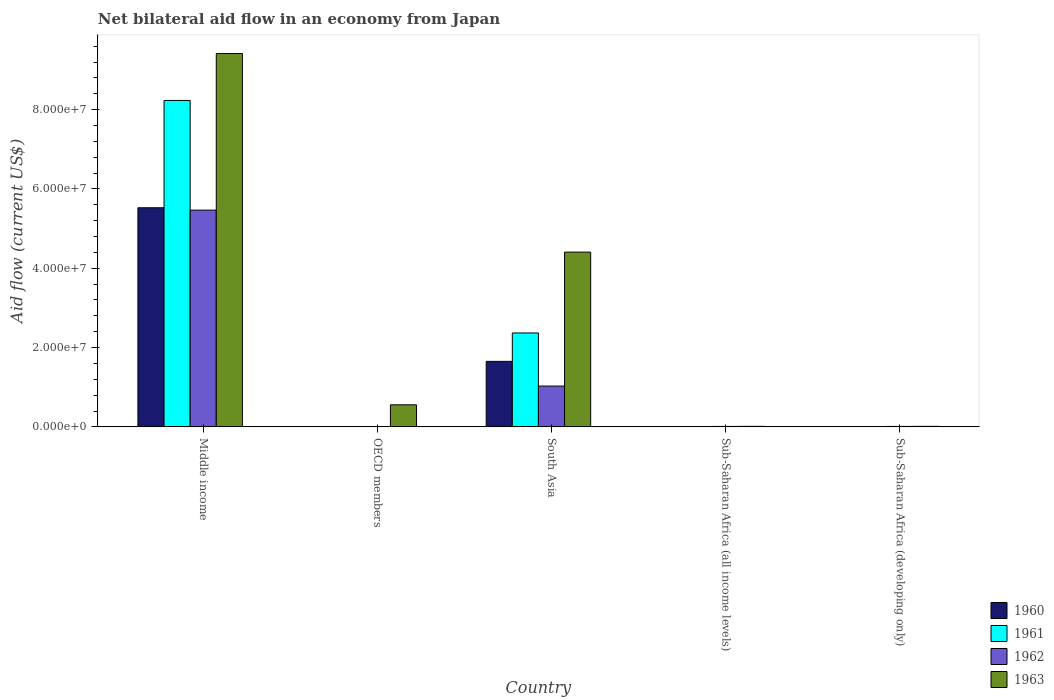How many groups of bars are there?
Keep it short and to the point. 5. Are the number of bars per tick equal to the number of legend labels?
Ensure brevity in your answer.  Yes. How many bars are there on the 2nd tick from the right?
Your response must be concise. 4. What is the label of the 4th group of bars from the left?
Give a very brief answer. Sub-Saharan Africa (all income levels). In how many cases, is the number of bars for a given country not equal to the number of legend labels?
Your response must be concise. 0. What is the net bilateral aid flow in 1963 in OECD members?
Provide a short and direct response. 5.56e+06. Across all countries, what is the maximum net bilateral aid flow in 1961?
Keep it short and to the point. 8.23e+07. What is the total net bilateral aid flow in 1960 in the graph?
Provide a succinct answer. 7.18e+07. What is the difference between the net bilateral aid flow in 1963 in South Asia and that in Sub-Saharan Africa (all income levels)?
Your answer should be very brief. 4.39e+07. What is the difference between the net bilateral aid flow in 1961 in South Asia and the net bilateral aid flow in 1960 in OECD members?
Your answer should be very brief. 2.36e+07. What is the average net bilateral aid flow in 1961 per country?
Give a very brief answer. 2.12e+07. What is the difference between the net bilateral aid flow of/in 1962 and net bilateral aid flow of/in 1961 in Sub-Saharan Africa (all income levels)?
Your answer should be very brief. 8.00e+04. What is the ratio of the net bilateral aid flow in 1961 in OECD members to that in South Asia?
Your answer should be very brief. 0. What is the difference between the highest and the second highest net bilateral aid flow in 1960?
Provide a succinct answer. 5.52e+07. What is the difference between the highest and the lowest net bilateral aid flow in 1961?
Give a very brief answer. 8.23e+07. What does the 4th bar from the right in South Asia represents?
Keep it short and to the point. 1960. Are the values on the major ticks of Y-axis written in scientific E-notation?
Ensure brevity in your answer.  Yes. What is the title of the graph?
Give a very brief answer. Net bilateral aid flow in an economy from Japan. What is the Aid flow (current US$) in 1960 in Middle income?
Ensure brevity in your answer.  5.53e+07. What is the Aid flow (current US$) of 1961 in Middle income?
Keep it short and to the point. 8.23e+07. What is the Aid flow (current US$) in 1962 in Middle income?
Your response must be concise. 5.47e+07. What is the Aid flow (current US$) of 1963 in Middle income?
Offer a very short reply. 9.42e+07. What is the Aid flow (current US$) in 1960 in OECD members?
Give a very brief answer. 3.00e+04. What is the Aid flow (current US$) in 1963 in OECD members?
Your answer should be very brief. 5.56e+06. What is the Aid flow (current US$) in 1960 in South Asia?
Offer a very short reply. 1.65e+07. What is the Aid flow (current US$) in 1961 in South Asia?
Your answer should be very brief. 2.37e+07. What is the Aid flow (current US$) in 1962 in South Asia?
Your response must be concise. 1.03e+07. What is the Aid flow (current US$) of 1963 in South Asia?
Make the answer very short. 4.41e+07. What is the Aid flow (current US$) of 1962 in Sub-Saharan Africa (all income levels)?
Offer a terse response. 1.10e+05. Across all countries, what is the maximum Aid flow (current US$) of 1960?
Keep it short and to the point. 5.53e+07. Across all countries, what is the maximum Aid flow (current US$) of 1961?
Make the answer very short. 8.23e+07. Across all countries, what is the maximum Aid flow (current US$) of 1962?
Offer a very short reply. 5.47e+07. Across all countries, what is the maximum Aid flow (current US$) of 1963?
Provide a succinct answer. 9.42e+07. Across all countries, what is the minimum Aid flow (current US$) of 1961?
Your answer should be compact. 3.00e+04. Across all countries, what is the minimum Aid flow (current US$) of 1962?
Offer a terse response. 9.00e+04. What is the total Aid flow (current US$) in 1960 in the graph?
Offer a terse response. 7.18e+07. What is the total Aid flow (current US$) of 1961 in the graph?
Make the answer very short. 1.06e+08. What is the total Aid flow (current US$) in 1962 in the graph?
Your response must be concise. 6.53e+07. What is the total Aid flow (current US$) in 1963 in the graph?
Your answer should be very brief. 1.44e+08. What is the difference between the Aid flow (current US$) of 1960 in Middle income and that in OECD members?
Make the answer very short. 5.52e+07. What is the difference between the Aid flow (current US$) in 1961 in Middle income and that in OECD members?
Offer a terse response. 8.23e+07. What is the difference between the Aid flow (current US$) of 1962 in Middle income and that in OECD members?
Offer a very short reply. 5.46e+07. What is the difference between the Aid flow (current US$) in 1963 in Middle income and that in OECD members?
Ensure brevity in your answer.  8.86e+07. What is the difference between the Aid flow (current US$) of 1960 in Middle income and that in South Asia?
Ensure brevity in your answer.  3.87e+07. What is the difference between the Aid flow (current US$) of 1961 in Middle income and that in South Asia?
Make the answer very short. 5.86e+07. What is the difference between the Aid flow (current US$) in 1962 in Middle income and that in South Asia?
Give a very brief answer. 4.44e+07. What is the difference between the Aid flow (current US$) in 1963 in Middle income and that in South Asia?
Provide a short and direct response. 5.01e+07. What is the difference between the Aid flow (current US$) of 1960 in Middle income and that in Sub-Saharan Africa (all income levels)?
Offer a very short reply. 5.52e+07. What is the difference between the Aid flow (current US$) in 1961 in Middle income and that in Sub-Saharan Africa (all income levels)?
Keep it short and to the point. 8.23e+07. What is the difference between the Aid flow (current US$) of 1962 in Middle income and that in Sub-Saharan Africa (all income levels)?
Offer a very short reply. 5.46e+07. What is the difference between the Aid flow (current US$) of 1963 in Middle income and that in Sub-Saharan Africa (all income levels)?
Offer a very short reply. 9.40e+07. What is the difference between the Aid flow (current US$) in 1960 in Middle income and that in Sub-Saharan Africa (developing only)?
Give a very brief answer. 5.52e+07. What is the difference between the Aid flow (current US$) in 1961 in Middle income and that in Sub-Saharan Africa (developing only)?
Make the answer very short. 8.23e+07. What is the difference between the Aid flow (current US$) of 1962 in Middle income and that in Sub-Saharan Africa (developing only)?
Provide a succinct answer. 5.46e+07. What is the difference between the Aid flow (current US$) in 1963 in Middle income and that in Sub-Saharan Africa (developing only)?
Offer a very short reply. 9.40e+07. What is the difference between the Aid flow (current US$) in 1960 in OECD members and that in South Asia?
Keep it short and to the point. -1.65e+07. What is the difference between the Aid flow (current US$) in 1961 in OECD members and that in South Asia?
Give a very brief answer. -2.36e+07. What is the difference between the Aid flow (current US$) of 1962 in OECD members and that in South Asia?
Ensure brevity in your answer.  -1.02e+07. What is the difference between the Aid flow (current US$) in 1963 in OECD members and that in South Asia?
Make the answer very short. -3.85e+07. What is the difference between the Aid flow (current US$) of 1962 in OECD members and that in Sub-Saharan Africa (all income levels)?
Offer a terse response. -2.00e+04. What is the difference between the Aid flow (current US$) of 1963 in OECD members and that in Sub-Saharan Africa (all income levels)?
Your response must be concise. 5.43e+06. What is the difference between the Aid flow (current US$) of 1963 in OECD members and that in Sub-Saharan Africa (developing only)?
Make the answer very short. 5.43e+06. What is the difference between the Aid flow (current US$) of 1960 in South Asia and that in Sub-Saharan Africa (all income levels)?
Provide a short and direct response. 1.65e+07. What is the difference between the Aid flow (current US$) in 1961 in South Asia and that in Sub-Saharan Africa (all income levels)?
Keep it short and to the point. 2.36e+07. What is the difference between the Aid flow (current US$) in 1962 in South Asia and that in Sub-Saharan Africa (all income levels)?
Ensure brevity in your answer.  1.02e+07. What is the difference between the Aid flow (current US$) of 1963 in South Asia and that in Sub-Saharan Africa (all income levels)?
Give a very brief answer. 4.39e+07. What is the difference between the Aid flow (current US$) in 1960 in South Asia and that in Sub-Saharan Africa (developing only)?
Keep it short and to the point. 1.65e+07. What is the difference between the Aid flow (current US$) of 1961 in South Asia and that in Sub-Saharan Africa (developing only)?
Your answer should be very brief. 2.36e+07. What is the difference between the Aid flow (current US$) in 1962 in South Asia and that in Sub-Saharan Africa (developing only)?
Give a very brief answer. 1.02e+07. What is the difference between the Aid flow (current US$) in 1963 in South Asia and that in Sub-Saharan Africa (developing only)?
Your answer should be very brief. 4.39e+07. What is the difference between the Aid flow (current US$) of 1961 in Sub-Saharan Africa (all income levels) and that in Sub-Saharan Africa (developing only)?
Offer a terse response. 0. What is the difference between the Aid flow (current US$) of 1962 in Sub-Saharan Africa (all income levels) and that in Sub-Saharan Africa (developing only)?
Provide a short and direct response. 0. What is the difference between the Aid flow (current US$) in 1963 in Sub-Saharan Africa (all income levels) and that in Sub-Saharan Africa (developing only)?
Your response must be concise. 0. What is the difference between the Aid flow (current US$) of 1960 in Middle income and the Aid flow (current US$) of 1961 in OECD members?
Ensure brevity in your answer.  5.52e+07. What is the difference between the Aid flow (current US$) of 1960 in Middle income and the Aid flow (current US$) of 1962 in OECD members?
Offer a very short reply. 5.52e+07. What is the difference between the Aid flow (current US$) of 1960 in Middle income and the Aid flow (current US$) of 1963 in OECD members?
Provide a succinct answer. 4.97e+07. What is the difference between the Aid flow (current US$) in 1961 in Middle income and the Aid flow (current US$) in 1962 in OECD members?
Keep it short and to the point. 8.22e+07. What is the difference between the Aid flow (current US$) in 1961 in Middle income and the Aid flow (current US$) in 1963 in OECD members?
Keep it short and to the point. 7.68e+07. What is the difference between the Aid flow (current US$) in 1962 in Middle income and the Aid flow (current US$) in 1963 in OECD members?
Keep it short and to the point. 4.91e+07. What is the difference between the Aid flow (current US$) in 1960 in Middle income and the Aid flow (current US$) in 1961 in South Asia?
Provide a succinct answer. 3.16e+07. What is the difference between the Aid flow (current US$) of 1960 in Middle income and the Aid flow (current US$) of 1962 in South Asia?
Your answer should be very brief. 4.50e+07. What is the difference between the Aid flow (current US$) in 1960 in Middle income and the Aid flow (current US$) in 1963 in South Asia?
Provide a succinct answer. 1.12e+07. What is the difference between the Aid flow (current US$) in 1961 in Middle income and the Aid flow (current US$) in 1962 in South Asia?
Your response must be concise. 7.20e+07. What is the difference between the Aid flow (current US$) of 1961 in Middle income and the Aid flow (current US$) of 1963 in South Asia?
Offer a very short reply. 3.82e+07. What is the difference between the Aid flow (current US$) of 1962 in Middle income and the Aid flow (current US$) of 1963 in South Asia?
Provide a succinct answer. 1.06e+07. What is the difference between the Aid flow (current US$) of 1960 in Middle income and the Aid flow (current US$) of 1961 in Sub-Saharan Africa (all income levels)?
Make the answer very short. 5.52e+07. What is the difference between the Aid flow (current US$) of 1960 in Middle income and the Aid flow (current US$) of 1962 in Sub-Saharan Africa (all income levels)?
Provide a short and direct response. 5.52e+07. What is the difference between the Aid flow (current US$) in 1960 in Middle income and the Aid flow (current US$) in 1963 in Sub-Saharan Africa (all income levels)?
Your response must be concise. 5.51e+07. What is the difference between the Aid flow (current US$) of 1961 in Middle income and the Aid flow (current US$) of 1962 in Sub-Saharan Africa (all income levels)?
Ensure brevity in your answer.  8.22e+07. What is the difference between the Aid flow (current US$) in 1961 in Middle income and the Aid flow (current US$) in 1963 in Sub-Saharan Africa (all income levels)?
Your response must be concise. 8.22e+07. What is the difference between the Aid flow (current US$) of 1962 in Middle income and the Aid flow (current US$) of 1963 in Sub-Saharan Africa (all income levels)?
Keep it short and to the point. 5.45e+07. What is the difference between the Aid flow (current US$) of 1960 in Middle income and the Aid flow (current US$) of 1961 in Sub-Saharan Africa (developing only)?
Ensure brevity in your answer.  5.52e+07. What is the difference between the Aid flow (current US$) of 1960 in Middle income and the Aid flow (current US$) of 1962 in Sub-Saharan Africa (developing only)?
Offer a terse response. 5.52e+07. What is the difference between the Aid flow (current US$) in 1960 in Middle income and the Aid flow (current US$) in 1963 in Sub-Saharan Africa (developing only)?
Your answer should be very brief. 5.51e+07. What is the difference between the Aid flow (current US$) in 1961 in Middle income and the Aid flow (current US$) in 1962 in Sub-Saharan Africa (developing only)?
Make the answer very short. 8.22e+07. What is the difference between the Aid flow (current US$) of 1961 in Middle income and the Aid flow (current US$) of 1963 in Sub-Saharan Africa (developing only)?
Your answer should be compact. 8.22e+07. What is the difference between the Aid flow (current US$) of 1962 in Middle income and the Aid flow (current US$) of 1963 in Sub-Saharan Africa (developing only)?
Offer a terse response. 5.45e+07. What is the difference between the Aid flow (current US$) in 1960 in OECD members and the Aid flow (current US$) in 1961 in South Asia?
Keep it short and to the point. -2.36e+07. What is the difference between the Aid flow (current US$) of 1960 in OECD members and the Aid flow (current US$) of 1962 in South Asia?
Your answer should be compact. -1.03e+07. What is the difference between the Aid flow (current US$) in 1960 in OECD members and the Aid flow (current US$) in 1963 in South Asia?
Provide a succinct answer. -4.40e+07. What is the difference between the Aid flow (current US$) of 1961 in OECD members and the Aid flow (current US$) of 1962 in South Asia?
Keep it short and to the point. -1.02e+07. What is the difference between the Aid flow (current US$) of 1961 in OECD members and the Aid flow (current US$) of 1963 in South Asia?
Provide a short and direct response. -4.40e+07. What is the difference between the Aid flow (current US$) of 1962 in OECD members and the Aid flow (current US$) of 1963 in South Asia?
Ensure brevity in your answer.  -4.40e+07. What is the difference between the Aid flow (current US$) of 1960 in OECD members and the Aid flow (current US$) of 1962 in Sub-Saharan Africa (all income levels)?
Provide a succinct answer. -8.00e+04. What is the difference between the Aid flow (current US$) in 1961 in OECD members and the Aid flow (current US$) in 1963 in Sub-Saharan Africa (all income levels)?
Your answer should be very brief. -8.00e+04. What is the difference between the Aid flow (current US$) in 1960 in OECD members and the Aid flow (current US$) in 1961 in Sub-Saharan Africa (developing only)?
Give a very brief answer. 0. What is the difference between the Aid flow (current US$) in 1960 in OECD members and the Aid flow (current US$) in 1963 in Sub-Saharan Africa (developing only)?
Give a very brief answer. -1.00e+05. What is the difference between the Aid flow (current US$) of 1962 in OECD members and the Aid flow (current US$) of 1963 in Sub-Saharan Africa (developing only)?
Offer a terse response. -4.00e+04. What is the difference between the Aid flow (current US$) of 1960 in South Asia and the Aid flow (current US$) of 1961 in Sub-Saharan Africa (all income levels)?
Make the answer very short. 1.65e+07. What is the difference between the Aid flow (current US$) in 1960 in South Asia and the Aid flow (current US$) in 1962 in Sub-Saharan Africa (all income levels)?
Your answer should be very brief. 1.64e+07. What is the difference between the Aid flow (current US$) in 1960 in South Asia and the Aid flow (current US$) in 1963 in Sub-Saharan Africa (all income levels)?
Your response must be concise. 1.64e+07. What is the difference between the Aid flow (current US$) of 1961 in South Asia and the Aid flow (current US$) of 1962 in Sub-Saharan Africa (all income levels)?
Offer a very short reply. 2.36e+07. What is the difference between the Aid flow (current US$) of 1961 in South Asia and the Aid flow (current US$) of 1963 in Sub-Saharan Africa (all income levels)?
Your answer should be very brief. 2.36e+07. What is the difference between the Aid flow (current US$) in 1962 in South Asia and the Aid flow (current US$) in 1963 in Sub-Saharan Africa (all income levels)?
Offer a very short reply. 1.02e+07. What is the difference between the Aid flow (current US$) of 1960 in South Asia and the Aid flow (current US$) of 1961 in Sub-Saharan Africa (developing only)?
Make the answer very short. 1.65e+07. What is the difference between the Aid flow (current US$) of 1960 in South Asia and the Aid flow (current US$) of 1962 in Sub-Saharan Africa (developing only)?
Keep it short and to the point. 1.64e+07. What is the difference between the Aid flow (current US$) of 1960 in South Asia and the Aid flow (current US$) of 1963 in Sub-Saharan Africa (developing only)?
Ensure brevity in your answer.  1.64e+07. What is the difference between the Aid flow (current US$) in 1961 in South Asia and the Aid flow (current US$) in 1962 in Sub-Saharan Africa (developing only)?
Keep it short and to the point. 2.36e+07. What is the difference between the Aid flow (current US$) of 1961 in South Asia and the Aid flow (current US$) of 1963 in Sub-Saharan Africa (developing only)?
Your answer should be compact. 2.36e+07. What is the difference between the Aid flow (current US$) in 1962 in South Asia and the Aid flow (current US$) in 1963 in Sub-Saharan Africa (developing only)?
Ensure brevity in your answer.  1.02e+07. What is the difference between the Aid flow (current US$) of 1960 in Sub-Saharan Africa (all income levels) and the Aid flow (current US$) of 1962 in Sub-Saharan Africa (developing only)?
Your response must be concise. -9.00e+04. What is the difference between the Aid flow (current US$) in 1962 in Sub-Saharan Africa (all income levels) and the Aid flow (current US$) in 1963 in Sub-Saharan Africa (developing only)?
Ensure brevity in your answer.  -2.00e+04. What is the average Aid flow (current US$) in 1960 per country?
Your answer should be very brief. 1.44e+07. What is the average Aid flow (current US$) of 1961 per country?
Offer a very short reply. 2.12e+07. What is the average Aid flow (current US$) of 1962 per country?
Your answer should be very brief. 1.31e+07. What is the average Aid flow (current US$) in 1963 per country?
Provide a short and direct response. 2.88e+07. What is the difference between the Aid flow (current US$) in 1960 and Aid flow (current US$) in 1961 in Middle income?
Your answer should be compact. -2.71e+07. What is the difference between the Aid flow (current US$) of 1960 and Aid flow (current US$) of 1962 in Middle income?
Your answer should be compact. 6.00e+05. What is the difference between the Aid flow (current US$) in 1960 and Aid flow (current US$) in 1963 in Middle income?
Offer a terse response. -3.89e+07. What is the difference between the Aid flow (current US$) in 1961 and Aid flow (current US$) in 1962 in Middle income?
Your response must be concise. 2.77e+07. What is the difference between the Aid flow (current US$) of 1961 and Aid flow (current US$) of 1963 in Middle income?
Provide a succinct answer. -1.18e+07. What is the difference between the Aid flow (current US$) in 1962 and Aid flow (current US$) in 1963 in Middle income?
Your response must be concise. -3.95e+07. What is the difference between the Aid flow (current US$) of 1960 and Aid flow (current US$) of 1962 in OECD members?
Your answer should be compact. -6.00e+04. What is the difference between the Aid flow (current US$) of 1960 and Aid flow (current US$) of 1963 in OECD members?
Ensure brevity in your answer.  -5.53e+06. What is the difference between the Aid flow (current US$) of 1961 and Aid flow (current US$) of 1962 in OECD members?
Your answer should be very brief. -4.00e+04. What is the difference between the Aid flow (current US$) in 1961 and Aid flow (current US$) in 1963 in OECD members?
Your response must be concise. -5.51e+06. What is the difference between the Aid flow (current US$) of 1962 and Aid flow (current US$) of 1963 in OECD members?
Your response must be concise. -5.47e+06. What is the difference between the Aid flow (current US$) in 1960 and Aid flow (current US$) in 1961 in South Asia?
Keep it short and to the point. -7.16e+06. What is the difference between the Aid flow (current US$) in 1960 and Aid flow (current US$) in 1962 in South Asia?
Give a very brief answer. 6.23e+06. What is the difference between the Aid flow (current US$) of 1960 and Aid flow (current US$) of 1963 in South Asia?
Give a very brief answer. -2.76e+07. What is the difference between the Aid flow (current US$) of 1961 and Aid flow (current US$) of 1962 in South Asia?
Provide a short and direct response. 1.34e+07. What is the difference between the Aid flow (current US$) in 1961 and Aid flow (current US$) in 1963 in South Asia?
Ensure brevity in your answer.  -2.04e+07. What is the difference between the Aid flow (current US$) in 1962 and Aid flow (current US$) in 1963 in South Asia?
Ensure brevity in your answer.  -3.38e+07. What is the difference between the Aid flow (current US$) of 1960 and Aid flow (current US$) of 1961 in Sub-Saharan Africa (all income levels)?
Offer a terse response. -10000. What is the difference between the Aid flow (current US$) of 1960 and Aid flow (current US$) of 1962 in Sub-Saharan Africa (all income levels)?
Keep it short and to the point. -9.00e+04. What is the difference between the Aid flow (current US$) in 1961 and Aid flow (current US$) in 1962 in Sub-Saharan Africa (all income levels)?
Your response must be concise. -8.00e+04. What is the difference between the Aid flow (current US$) of 1961 and Aid flow (current US$) of 1963 in Sub-Saharan Africa (all income levels)?
Offer a terse response. -1.00e+05. What is the difference between the Aid flow (current US$) in 1961 and Aid flow (current US$) in 1963 in Sub-Saharan Africa (developing only)?
Offer a terse response. -1.00e+05. What is the difference between the Aid flow (current US$) in 1962 and Aid flow (current US$) in 1963 in Sub-Saharan Africa (developing only)?
Your answer should be compact. -2.00e+04. What is the ratio of the Aid flow (current US$) in 1960 in Middle income to that in OECD members?
Provide a short and direct response. 1842. What is the ratio of the Aid flow (current US$) in 1961 in Middle income to that in OECD members?
Give a very brief answer. 1646.4. What is the ratio of the Aid flow (current US$) in 1962 in Middle income to that in OECD members?
Your answer should be compact. 607.33. What is the ratio of the Aid flow (current US$) of 1963 in Middle income to that in OECD members?
Provide a short and direct response. 16.93. What is the ratio of the Aid flow (current US$) in 1960 in Middle income to that in South Asia?
Provide a succinct answer. 3.35. What is the ratio of the Aid flow (current US$) in 1961 in Middle income to that in South Asia?
Offer a very short reply. 3.48. What is the ratio of the Aid flow (current US$) in 1962 in Middle income to that in South Asia?
Provide a succinct answer. 5.31. What is the ratio of the Aid flow (current US$) in 1963 in Middle income to that in South Asia?
Make the answer very short. 2.14. What is the ratio of the Aid flow (current US$) in 1960 in Middle income to that in Sub-Saharan Africa (all income levels)?
Your response must be concise. 2763. What is the ratio of the Aid flow (current US$) in 1961 in Middle income to that in Sub-Saharan Africa (all income levels)?
Your response must be concise. 2744. What is the ratio of the Aid flow (current US$) of 1962 in Middle income to that in Sub-Saharan Africa (all income levels)?
Your response must be concise. 496.91. What is the ratio of the Aid flow (current US$) in 1963 in Middle income to that in Sub-Saharan Africa (all income levels)?
Offer a very short reply. 724.23. What is the ratio of the Aid flow (current US$) in 1960 in Middle income to that in Sub-Saharan Africa (developing only)?
Give a very brief answer. 2763. What is the ratio of the Aid flow (current US$) in 1961 in Middle income to that in Sub-Saharan Africa (developing only)?
Keep it short and to the point. 2744. What is the ratio of the Aid flow (current US$) in 1962 in Middle income to that in Sub-Saharan Africa (developing only)?
Your answer should be compact. 496.91. What is the ratio of the Aid flow (current US$) in 1963 in Middle income to that in Sub-Saharan Africa (developing only)?
Provide a succinct answer. 724.23. What is the ratio of the Aid flow (current US$) in 1960 in OECD members to that in South Asia?
Provide a succinct answer. 0. What is the ratio of the Aid flow (current US$) in 1961 in OECD members to that in South Asia?
Provide a succinct answer. 0. What is the ratio of the Aid flow (current US$) of 1962 in OECD members to that in South Asia?
Ensure brevity in your answer.  0.01. What is the ratio of the Aid flow (current US$) of 1963 in OECD members to that in South Asia?
Provide a succinct answer. 0.13. What is the ratio of the Aid flow (current US$) of 1961 in OECD members to that in Sub-Saharan Africa (all income levels)?
Offer a very short reply. 1.67. What is the ratio of the Aid flow (current US$) in 1962 in OECD members to that in Sub-Saharan Africa (all income levels)?
Offer a terse response. 0.82. What is the ratio of the Aid flow (current US$) in 1963 in OECD members to that in Sub-Saharan Africa (all income levels)?
Make the answer very short. 42.77. What is the ratio of the Aid flow (current US$) of 1961 in OECD members to that in Sub-Saharan Africa (developing only)?
Your answer should be compact. 1.67. What is the ratio of the Aid flow (current US$) of 1962 in OECD members to that in Sub-Saharan Africa (developing only)?
Give a very brief answer. 0.82. What is the ratio of the Aid flow (current US$) of 1963 in OECD members to that in Sub-Saharan Africa (developing only)?
Provide a short and direct response. 42.77. What is the ratio of the Aid flow (current US$) in 1960 in South Asia to that in Sub-Saharan Africa (all income levels)?
Provide a short and direct response. 826. What is the ratio of the Aid flow (current US$) of 1961 in South Asia to that in Sub-Saharan Africa (all income levels)?
Offer a terse response. 789.33. What is the ratio of the Aid flow (current US$) of 1962 in South Asia to that in Sub-Saharan Africa (all income levels)?
Make the answer very short. 93.55. What is the ratio of the Aid flow (current US$) in 1963 in South Asia to that in Sub-Saharan Africa (all income levels)?
Offer a terse response. 339. What is the ratio of the Aid flow (current US$) in 1960 in South Asia to that in Sub-Saharan Africa (developing only)?
Keep it short and to the point. 826. What is the ratio of the Aid flow (current US$) of 1961 in South Asia to that in Sub-Saharan Africa (developing only)?
Your answer should be very brief. 789.33. What is the ratio of the Aid flow (current US$) of 1962 in South Asia to that in Sub-Saharan Africa (developing only)?
Give a very brief answer. 93.55. What is the ratio of the Aid flow (current US$) of 1963 in South Asia to that in Sub-Saharan Africa (developing only)?
Provide a succinct answer. 339. What is the ratio of the Aid flow (current US$) in 1960 in Sub-Saharan Africa (all income levels) to that in Sub-Saharan Africa (developing only)?
Provide a short and direct response. 1. What is the ratio of the Aid flow (current US$) of 1963 in Sub-Saharan Africa (all income levels) to that in Sub-Saharan Africa (developing only)?
Offer a terse response. 1. What is the difference between the highest and the second highest Aid flow (current US$) of 1960?
Offer a very short reply. 3.87e+07. What is the difference between the highest and the second highest Aid flow (current US$) of 1961?
Your answer should be compact. 5.86e+07. What is the difference between the highest and the second highest Aid flow (current US$) of 1962?
Provide a short and direct response. 4.44e+07. What is the difference between the highest and the second highest Aid flow (current US$) in 1963?
Provide a short and direct response. 5.01e+07. What is the difference between the highest and the lowest Aid flow (current US$) in 1960?
Provide a short and direct response. 5.52e+07. What is the difference between the highest and the lowest Aid flow (current US$) of 1961?
Your answer should be very brief. 8.23e+07. What is the difference between the highest and the lowest Aid flow (current US$) in 1962?
Offer a terse response. 5.46e+07. What is the difference between the highest and the lowest Aid flow (current US$) in 1963?
Your answer should be compact. 9.40e+07. 